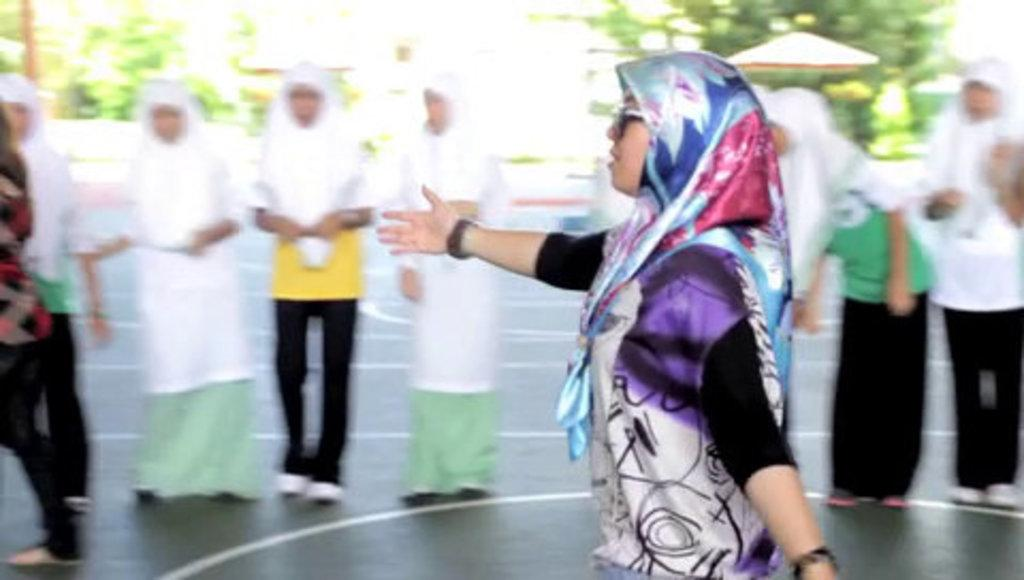Who is the main subject in the image? There is a woman in the image. What is the woman wearing? The woman is wearing a dress. What can be seen at the bottom of the image? There is a road at the bottom of the image. What is located in the middle of the image? There are people and trees in the middle of the image. What type of scent can be detected in the image? There is no information about any scent in the image, so it cannot be determined. 